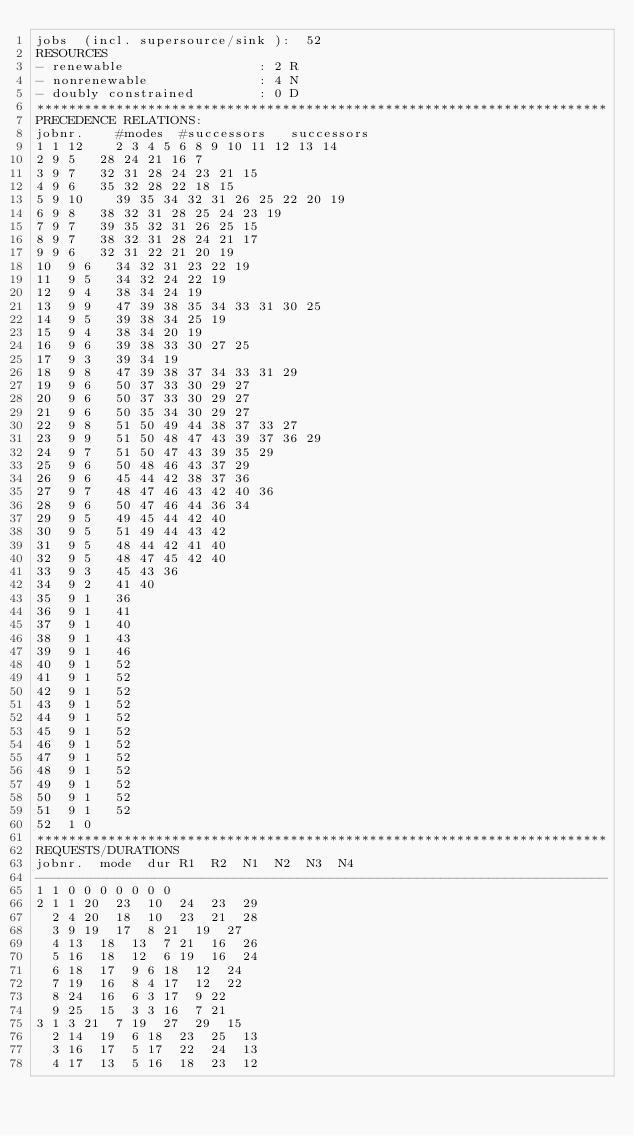Convert code to text. <code><loc_0><loc_0><loc_500><loc_500><_ObjectiveC_>jobs  (incl. supersource/sink ):	52
RESOURCES
- renewable                 : 2 R
- nonrenewable              : 4 N
- doubly constrained        : 0 D
************************************************************************
PRECEDENCE RELATIONS:
jobnr.    #modes  #successors   successors
1	1	12		2 3 4 5 6 8 9 10 11 12 13 14 
2	9	5		28 24 21 16 7 
3	9	7		32 31 28 24 23 21 15 
4	9	6		35 32 28 22 18 15 
5	9	10		39 35 34 32 31 26 25 22 20 19 
6	9	8		38 32 31 28 25 24 23 19 
7	9	7		39 35 32 31 26 25 15 
8	9	7		38 32 31 28 24 21 17 
9	9	6		32 31 22 21 20 19 
10	9	6		34 32 31 23 22 19 
11	9	5		34 32 24 22 19 
12	9	4		38 34 24 19 
13	9	9		47 39 38 35 34 33 31 30 25 
14	9	5		39 38 34 25 19 
15	9	4		38 34 20 19 
16	9	6		39 38 33 30 27 25 
17	9	3		39 34 19 
18	9	8		47 39 38 37 34 33 31 29 
19	9	6		50 37 33 30 29 27 
20	9	6		50 37 33 30 29 27 
21	9	6		50 35 34 30 29 27 
22	9	8		51 50 49 44 38 37 33 27 
23	9	9		51 50 48 47 43 39 37 36 29 
24	9	7		51 50 47 43 39 35 29 
25	9	6		50 48 46 43 37 29 
26	9	6		45 44 42 38 37 36 
27	9	7		48 47 46 43 42 40 36 
28	9	6		50 47 46 44 36 34 
29	9	5		49 45 44 42 40 
30	9	5		51 49 44 43 42 
31	9	5		48 44 42 41 40 
32	9	5		48 47 45 42 40 
33	9	3		45 43 36 
34	9	2		41 40 
35	9	1		36 
36	9	1		41 
37	9	1		40 
38	9	1		43 
39	9	1		46 
40	9	1		52 
41	9	1		52 
42	9	1		52 
43	9	1		52 
44	9	1		52 
45	9	1		52 
46	9	1		52 
47	9	1		52 
48	9	1		52 
49	9	1		52 
50	9	1		52 
51	9	1		52 
52	1	0		
************************************************************************
REQUESTS/DURATIONS
jobnr.	mode	dur	R1	R2	N1	N2	N3	N4	
------------------------------------------------------------------------
1	1	0	0	0	0	0	0	0	
2	1	1	20	23	10	24	23	29	
	2	4	20	18	10	23	21	28	
	3	9	19	17	8	21	19	27	
	4	13	18	13	7	21	16	26	
	5	16	18	12	6	19	16	24	
	6	18	17	9	6	18	12	24	
	7	19	16	8	4	17	12	22	
	8	24	16	6	3	17	9	22	
	9	25	15	3	3	16	7	21	
3	1	3	21	7	19	27	29	15	
	2	14	19	6	18	23	25	13	
	3	16	17	5	17	22	24	13	
	4	17	13	5	16	18	23	12	</code> 